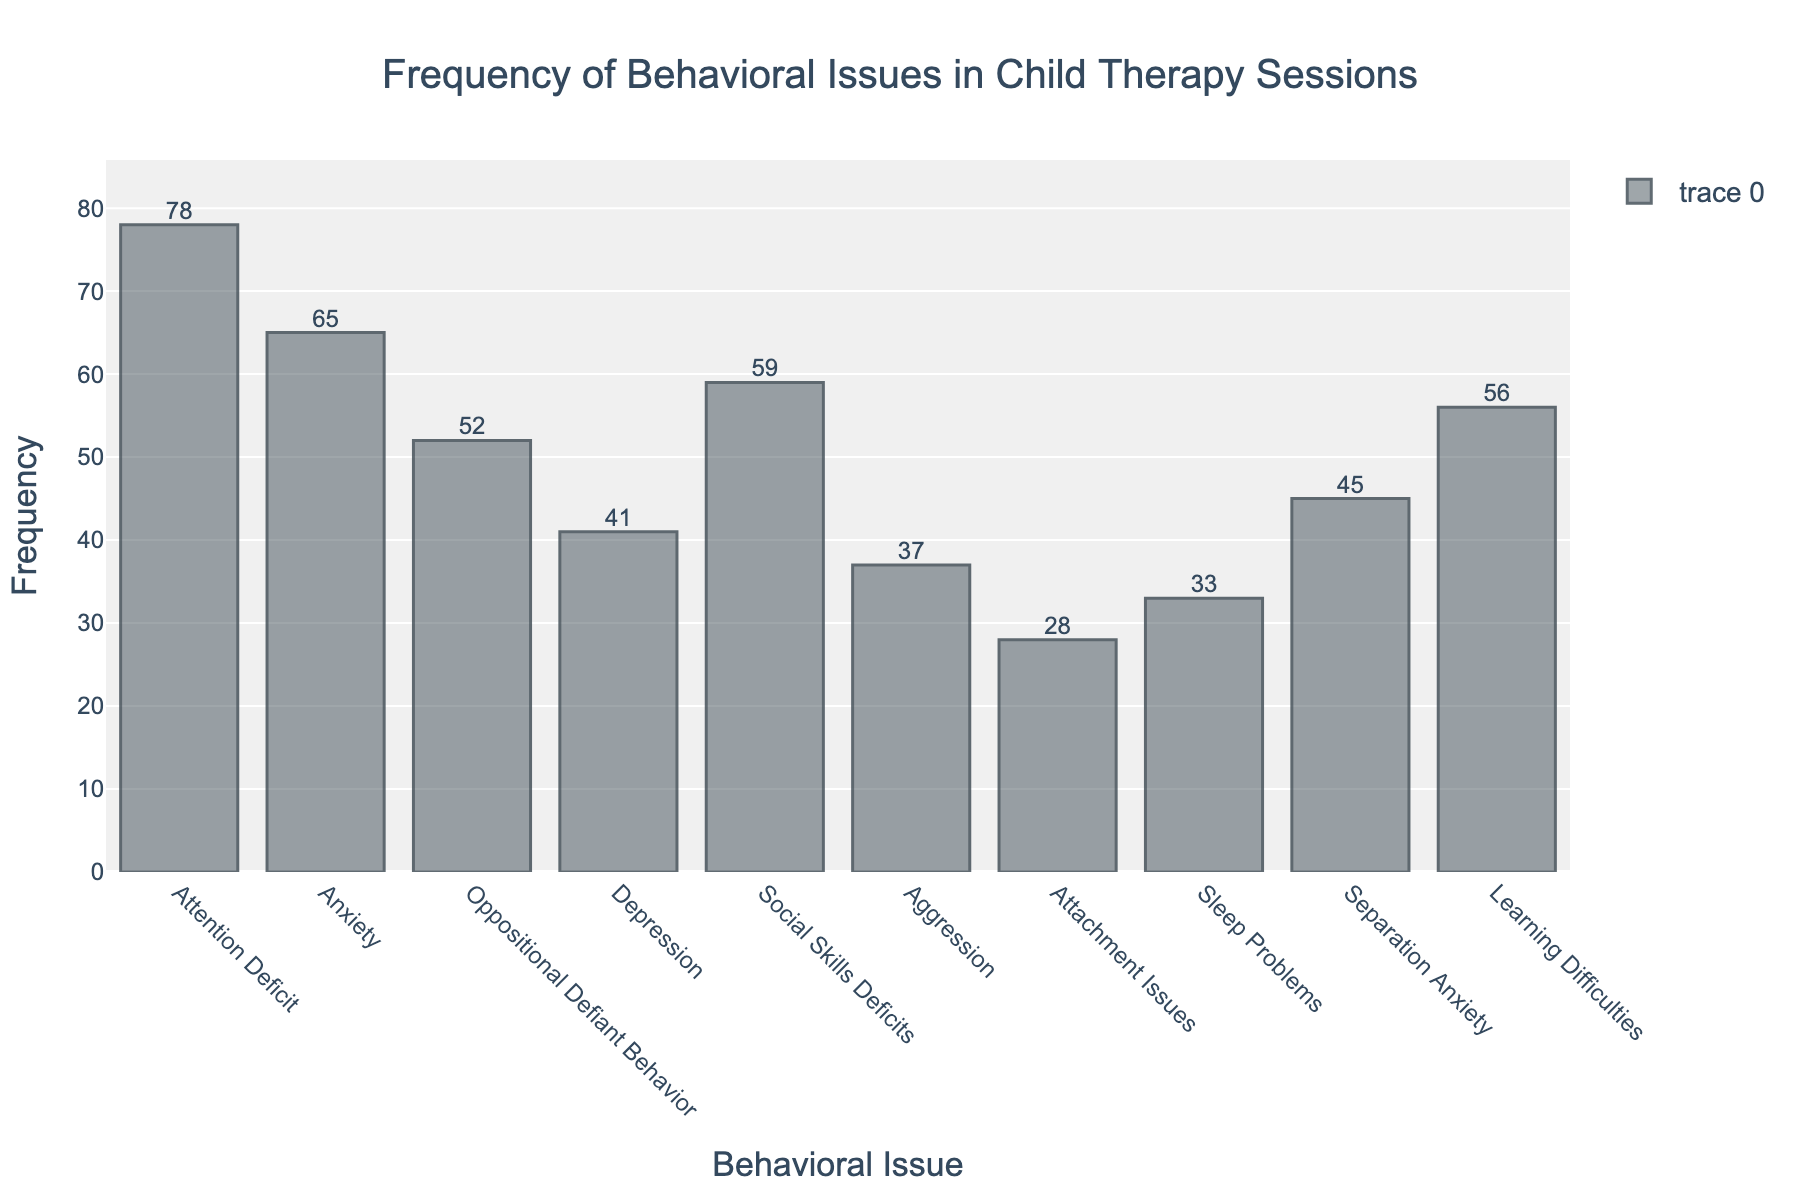What's the title of the figure? The title of the figure is shown at the top of the plot, centered and in a larger font size. It reads "Frequency of Behavioral Issues in Child Therapy Sessions".
Answer: "Frequency of Behavioral Issues in Child Therapy Sessions" What are the axes labels? The labels of the axes are located near the axes. The x-axis is labeled "Behavioral Issue" and the y-axis is labeled "Frequency".
Answer: "Behavioral Issue" and "Frequency" How many behavioral issues are listed? Count the number of distinct bars on the x-axis. Each bar represents one behavioral issue. There are ten bars.
Answer: 10 Which behavioral issue has the highest frequency? Identify the tallest bar on the histogram, which corresponds to the highest frequency. The tallest bar is labeled "Attention Deficit" with a frequency of 78.
Answer: Attention Deficit What is the frequency of Social Skills Deficits? Look at the height of the bar labeled "Social Skills Deficits" on the x-axis. The frequency value displayed on top of the bar is 59.
Answer: 59 What is the combined frequency of Anxiety and Depression? Find the frequencies for both "Anxiety" and "Depression" by looking at their respective bars: Anxiety (65) and Depression (41). Add these values together (65 + 41 = 106).
Answer: 106 How much greater is the frequency of Attention Deficit compared to Attachment Issues? Identify the frequencies of both "Attention Deficit" (78) and "Attachment Issues" (28). Subtract the lower frequency from the higher frequency (78 - 28 = 50).
Answer: 50 What is the median frequency value of the listed behavioral issues? List the frequencies in ascending order: 28, 33, 37, 41, 45, 52, 56, 59, 65, 78. The median is the middle value in this ordered list. Since there are 10 values, the median is the average of the 5th and 6th values ((45 + 52) / 2 = 48.5).
Answer: 48.5 Which behavioral issues have frequencies greater than 50? Observe the bars whose heights exceed the frequency value of 50 and note the labels: Attention Deficit (78), Anxiety (65), Oppositional Defiant Behavior (52), Social Skills Deficits (59), and Learning Difficulties (56).
Answer: Attention Deficit, Anxiety, Oppositional Defiant Behavior, Social Skills Deficits, Learning Difficulties What is the average frequency of all behavioral issues? Add all the frequencies together (78 + 65 + 52 + 41 + 59 + 37 + 28 + 33 + 45 + 56 = 494) and divide by the number of issues (10). The average is 494 / 10 = 49.4.
Answer: 49.4 